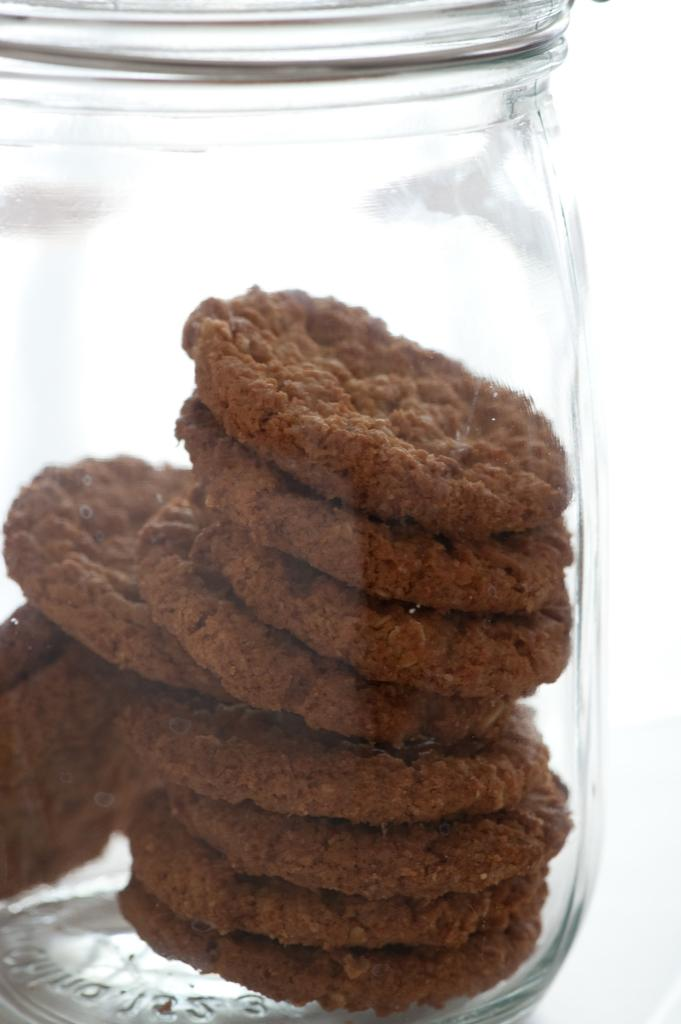What object in the image is made of glass? There is a glass jar in the image. What is inside the glass jar? The glass jar contains brown cookies or biscuits. What type of idea is represented by the quince in the image? There is no quince present in the image; it only contains brown cookies or biscuits in a glass jar. 